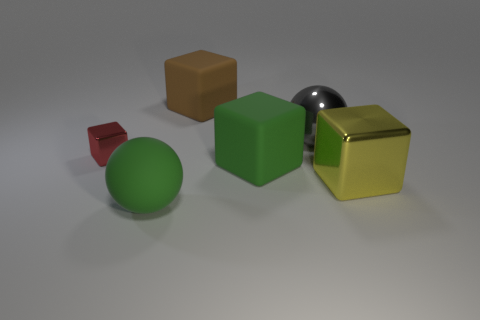Add 2 small red things. How many objects exist? 8 Subtract all purple cubes. Subtract all purple spheres. How many cubes are left? 4 Subtract all spheres. How many objects are left? 4 Add 3 spheres. How many spheres exist? 5 Subtract 0 cyan spheres. How many objects are left? 6 Subtract all brown matte cubes. Subtract all large objects. How many objects are left? 0 Add 6 big green rubber things. How many big green rubber things are left? 8 